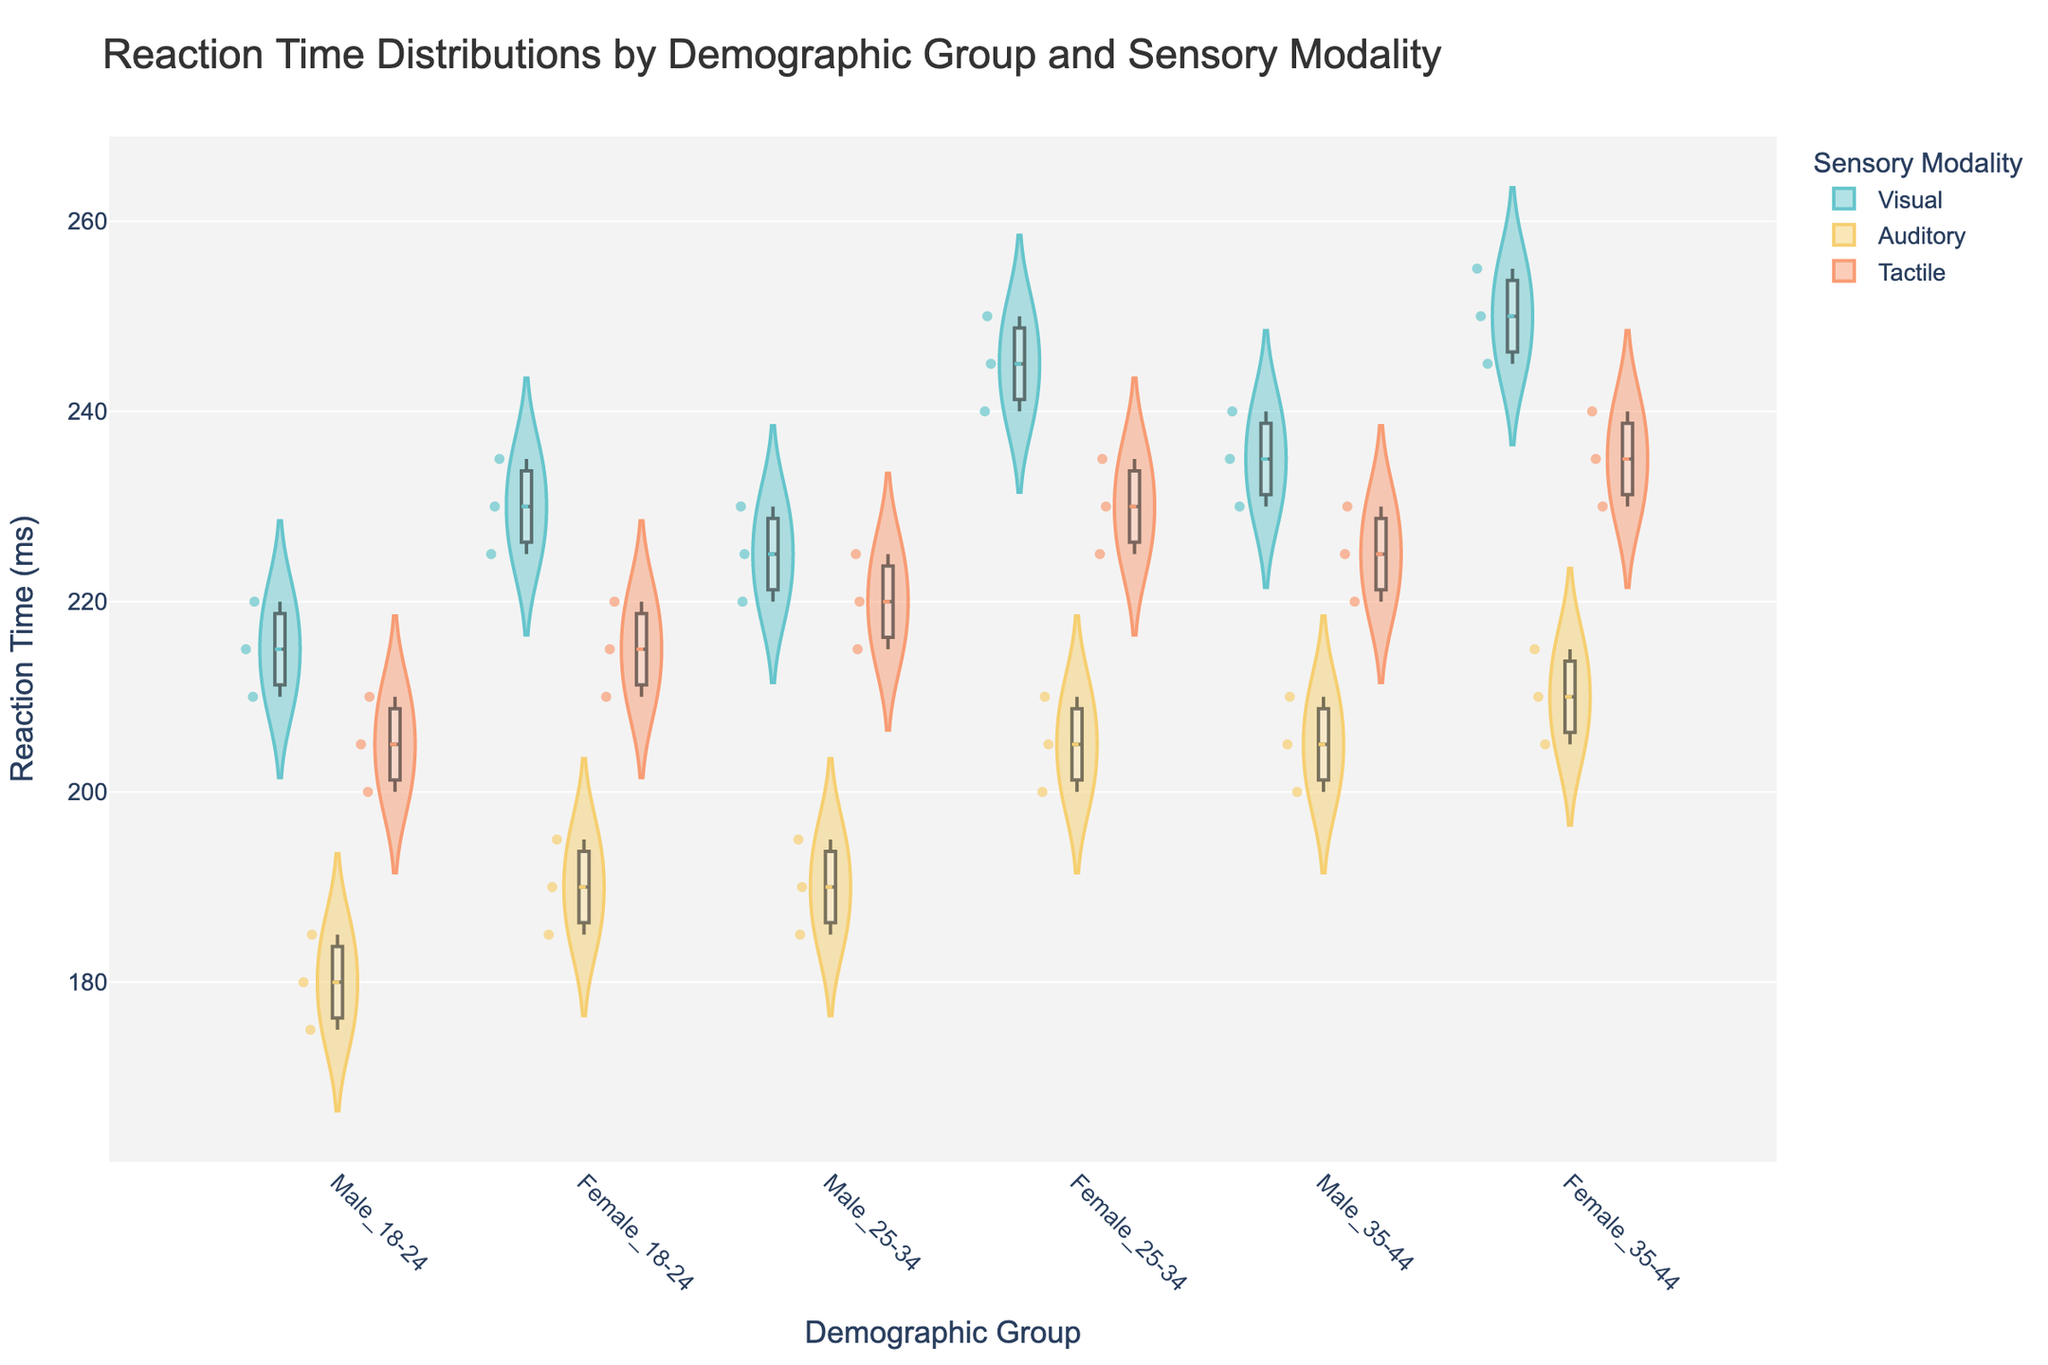What is the title of the figure? The title of the figure can generally be found at the top of the chart. In this case, the title is provided in the code and should be displayed at the top.
Answer: Reaction Time Distributions by Demographic Group and Sensory Modality Which demographic group has the lowest median reaction time for the auditory modality? To find the lowest median reaction time for the auditory modality, look for the median lines within the box plots for each demographic group and sensory modality combination. The median line is the horizontal line inside the boxes on the violin plots. The lowest one should correspond to the group with the lowest median reaction time.
Answer: Male_18-24 How do the reaction times for visual modality differ between males aged 18-24 and 25-34? To compare these groups, observe the position and spread of the violin plots for the visual modality in both demographic groups (Male_18-24 and Male_25-34). Look at the central tendency (median) and variation (distribution width).
Answer: Males aged 25-34 have a slightly higher median reaction time and a slightly wider distribution for visual modality compared to those aged 18-24 Which sensory modality has the smallest interquartile range for females aged 35-44? To determine the smallest interquartile range (IQR), compare the heights of the boxes within the violin plots for each sensory modality for Females aged 35-44. The IQR is the height of the box, from the first to the third quartile.
Answer: Auditory Between Females aged 25-34 and Males aged 25-34, which group shows more variability in reaction times for visual modality? Variability can be assessed by the width and spread of the violin plots. Compare the shapes of the violin plots for visual modality between the two groups to see which one has a wider spread.
Answer: Females aged 25-34 What are the mean reaction times for tactile modality across all demographic groups? The mean reaction time is represented by a line within each violin plot. Locate these lines for the tactile modality across all demographic groups and note their positions.
Answer: Around 210-235 ms Which group has a higher median reaction time for tactile modality, Male_35-44 or Female_35-44? The median reaction time is indicated by a line within the box plot. Examine the median lines within the tactile modality for both groups to determine which is higher.
Answer: Female_35-44 How do the distributions of reaction times in the auditory modality compare between males and females aged 18-24? Compare the shapes, widths, and heights of the violin plots for the auditory modality for Males_18-24 and Females_18-24. Look at where most of the data is concentrated and how spread out the reaction times are.
Answer: Males have a slightly lower concentration of reaction times with a smaller spread compared to females What is the overall trend in reaction times for visual modality across the different age groups? To see the trend, observe the median lines for visual modality across all age groups. Compare if the reaction times increase, decrease, or remain relatively constant across different demographics.
Answer: Reaction times generally increase with age Is there a demographic group with notably high or low reaction times for any sensory modality? Look at the violin plots that stand out in terms of highest or lowest central tendencies or wide/narrow distributions. Identify any demographic group that has an exceptionally high or low reaction time for any modality.
Answer: Females aged 35-44 have notably high reaction times for visual modality 